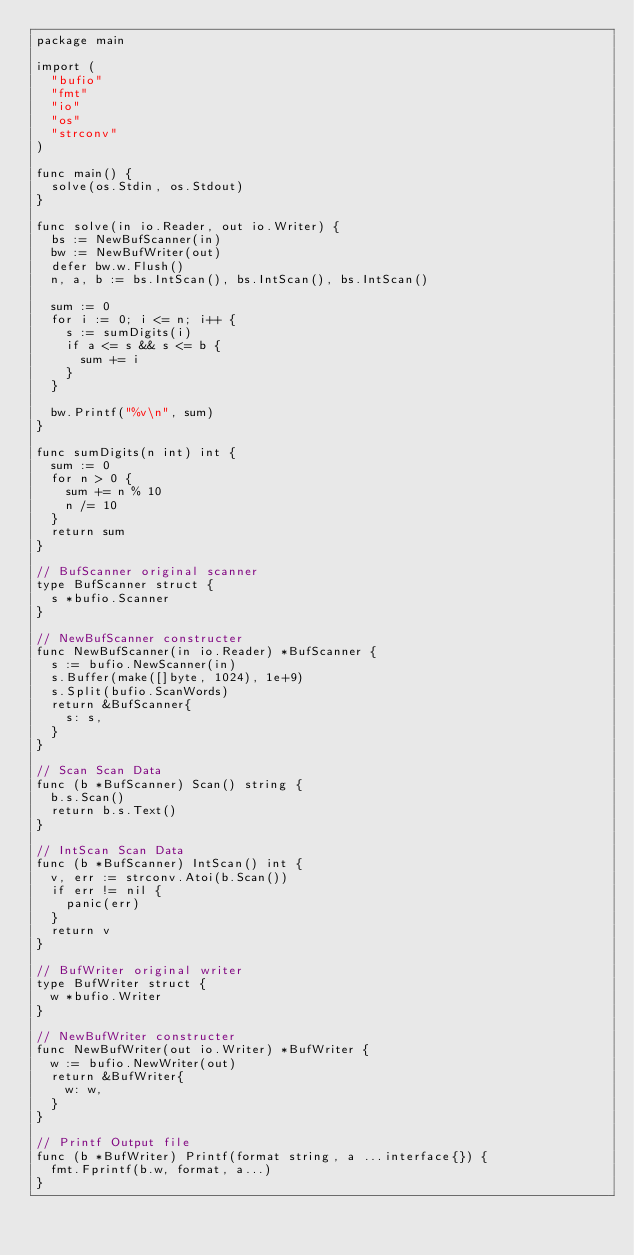<code> <loc_0><loc_0><loc_500><loc_500><_Go_>package main

import (
	"bufio"
	"fmt"
	"io"
	"os"
	"strconv"
)

func main() {
	solve(os.Stdin, os.Stdout)
}

func solve(in io.Reader, out io.Writer) {
	bs := NewBufScanner(in)
	bw := NewBufWriter(out)
	defer bw.w.Flush()
	n, a, b := bs.IntScan(), bs.IntScan(), bs.IntScan()

	sum := 0
	for i := 0; i <= n; i++ {
		s := sumDigits(i)
		if a <= s && s <= b {
			sum += i
		}
	}

	bw.Printf("%v\n", sum)
}

func sumDigits(n int) int {
	sum := 0
	for n > 0 {
		sum += n % 10
		n /= 10
	}
	return sum
}

// BufScanner original scanner
type BufScanner struct {
	s *bufio.Scanner
}

// NewBufScanner constructer
func NewBufScanner(in io.Reader) *BufScanner {
	s := bufio.NewScanner(in)
	s.Buffer(make([]byte, 1024), 1e+9)
	s.Split(bufio.ScanWords)
	return &BufScanner{
		s: s,
	}
}

// Scan Scan Data
func (b *BufScanner) Scan() string {
	b.s.Scan()
	return b.s.Text()
}

// IntScan Scan Data
func (b *BufScanner) IntScan() int {
	v, err := strconv.Atoi(b.Scan())
	if err != nil {
		panic(err)
	}
	return v
}

// BufWriter original writer
type BufWriter struct {
	w *bufio.Writer
}

// NewBufWriter constructer
func NewBufWriter(out io.Writer) *BufWriter {
	w := bufio.NewWriter(out)
	return &BufWriter{
		w: w,
	}
}

// Printf Output file
func (b *BufWriter) Printf(format string, a ...interface{}) {
	fmt.Fprintf(b.w, format, a...)
}</code> 